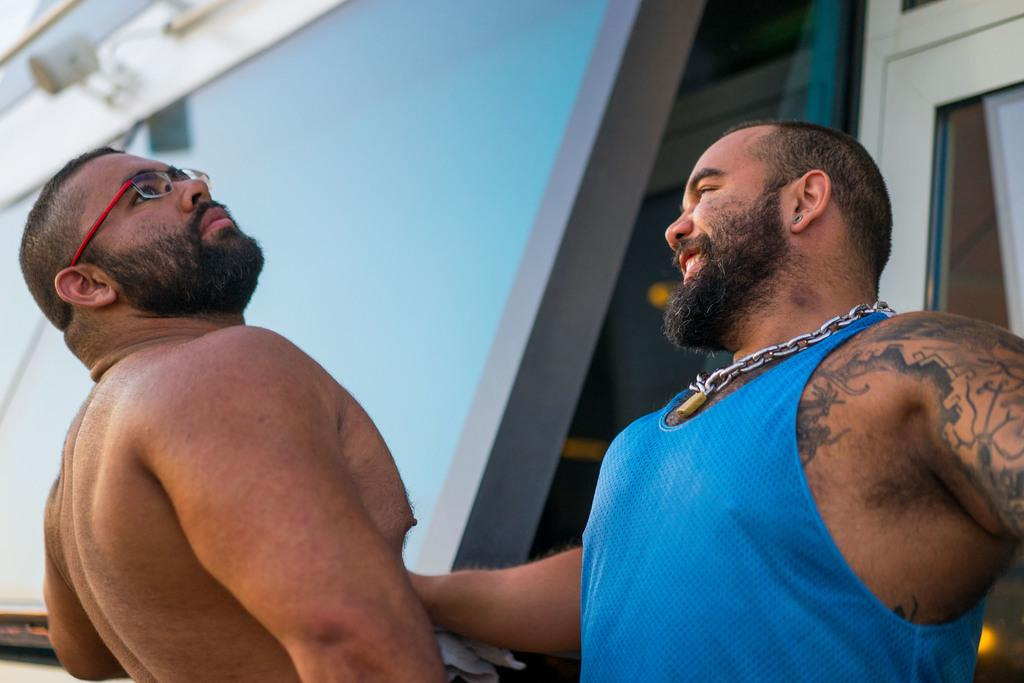How many people are present in the image? There are two people in the image. What else can be seen in the image besides the people? There are objects and lights in the image. What page is the person reading from in the image? There is no page or book visible in the image, so it cannot be determined if someone is reading. 